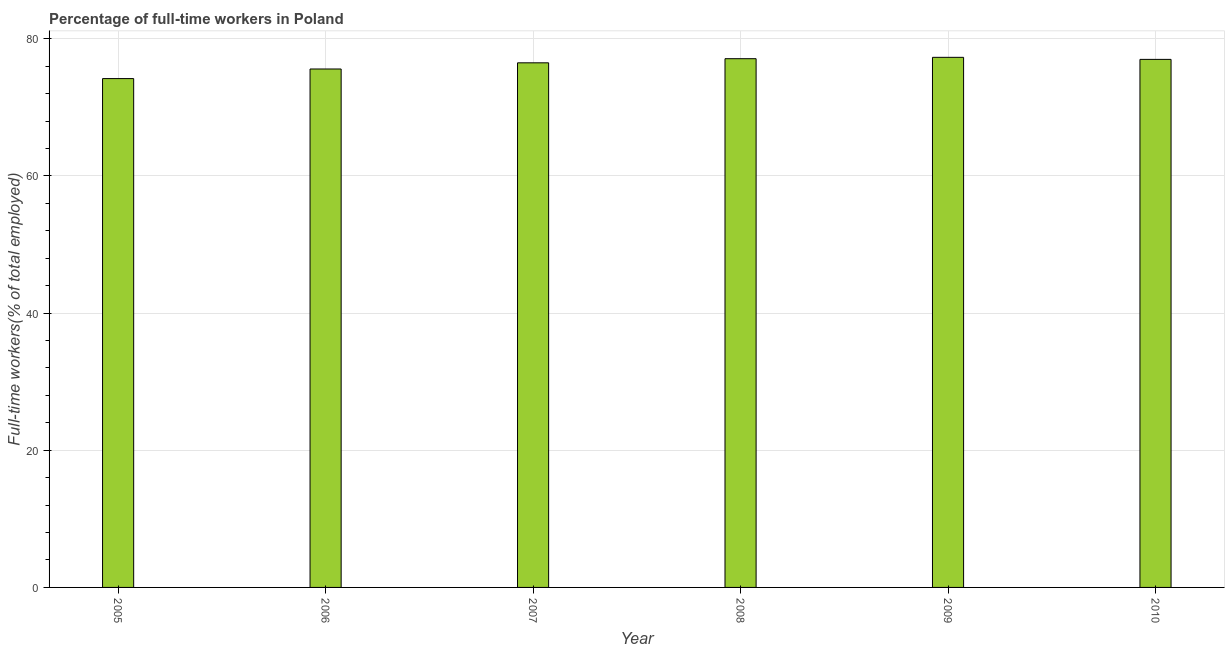Does the graph contain any zero values?
Provide a short and direct response. No. Does the graph contain grids?
Provide a succinct answer. Yes. What is the title of the graph?
Your answer should be very brief. Percentage of full-time workers in Poland. What is the label or title of the X-axis?
Your response must be concise. Year. What is the label or title of the Y-axis?
Ensure brevity in your answer.  Full-time workers(% of total employed). What is the percentage of full-time workers in 2009?
Give a very brief answer. 77.3. Across all years, what is the maximum percentage of full-time workers?
Provide a short and direct response. 77.3. Across all years, what is the minimum percentage of full-time workers?
Offer a very short reply. 74.2. What is the sum of the percentage of full-time workers?
Your response must be concise. 457.7. What is the difference between the percentage of full-time workers in 2005 and 2010?
Ensure brevity in your answer.  -2.8. What is the average percentage of full-time workers per year?
Give a very brief answer. 76.28. What is the median percentage of full-time workers?
Keep it short and to the point. 76.75. In how many years, is the percentage of full-time workers greater than 68 %?
Provide a succinct answer. 6. Is the percentage of full-time workers in 2007 less than that in 2010?
Ensure brevity in your answer.  Yes. Is the difference between the percentage of full-time workers in 2006 and 2010 greater than the difference between any two years?
Offer a very short reply. No. What is the difference between the highest and the second highest percentage of full-time workers?
Your answer should be very brief. 0.2. What is the difference between the highest and the lowest percentage of full-time workers?
Ensure brevity in your answer.  3.1. Are all the bars in the graph horizontal?
Keep it short and to the point. No. Are the values on the major ticks of Y-axis written in scientific E-notation?
Keep it short and to the point. No. What is the Full-time workers(% of total employed) in 2005?
Offer a very short reply. 74.2. What is the Full-time workers(% of total employed) of 2006?
Give a very brief answer. 75.6. What is the Full-time workers(% of total employed) in 2007?
Keep it short and to the point. 76.5. What is the Full-time workers(% of total employed) of 2008?
Your response must be concise. 77.1. What is the Full-time workers(% of total employed) of 2009?
Provide a short and direct response. 77.3. What is the Full-time workers(% of total employed) in 2010?
Provide a short and direct response. 77. What is the difference between the Full-time workers(% of total employed) in 2005 and 2009?
Offer a very short reply. -3.1. What is the difference between the Full-time workers(% of total employed) in 2005 and 2010?
Your answer should be compact. -2.8. What is the difference between the Full-time workers(% of total employed) in 2006 and 2007?
Offer a very short reply. -0.9. What is the difference between the Full-time workers(% of total employed) in 2008 and 2009?
Your response must be concise. -0.2. What is the difference between the Full-time workers(% of total employed) in 2008 and 2010?
Your response must be concise. 0.1. What is the difference between the Full-time workers(% of total employed) in 2009 and 2010?
Offer a very short reply. 0.3. What is the ratio of the Full-time workers(% of total employed) in 2005 to that in 2006?
Offer a very short reply. 0.98. What is the ratio of the Full-time workers(% of total employed) in 2005 to that in 2007?
Ensure brevity in your answer.  0.97. What is the ratio of the Full-time workers(% of total employed) in 2006 to that in 2007?
Your response must be concise. 0.99. What is the ratio of the Full-time workers(% of total employed) in 2006 to that in 2008?
Keep it short and to the point. 0.98. What is the ratio of the Full-time workers(% of total employed) in 2006 to that in 2010?
Your response must be concise. 0.98. What is the ratio of the Full-time workers(% of total employed) in 2007 to that in 2009?
Ensure brevity in your answer.  0.99. What is the ratio of the Full-time workers(% of total employed) in 2007 to that in 2010?
Keep it short and to the point. 0.99. What is the ratio of the Full-time workers(% of total employed) in 2008 to that in 2009?
Provide a short and direct response. 1. What is the ratio of the Full-time workers(% of total employed) in 2008 to that in 2010?
Your answer should be compact. 1. What is the ratio of the Full-time workers(% of total employed) in 2009 to that in 2010?
Offer a very short reply. 1. 